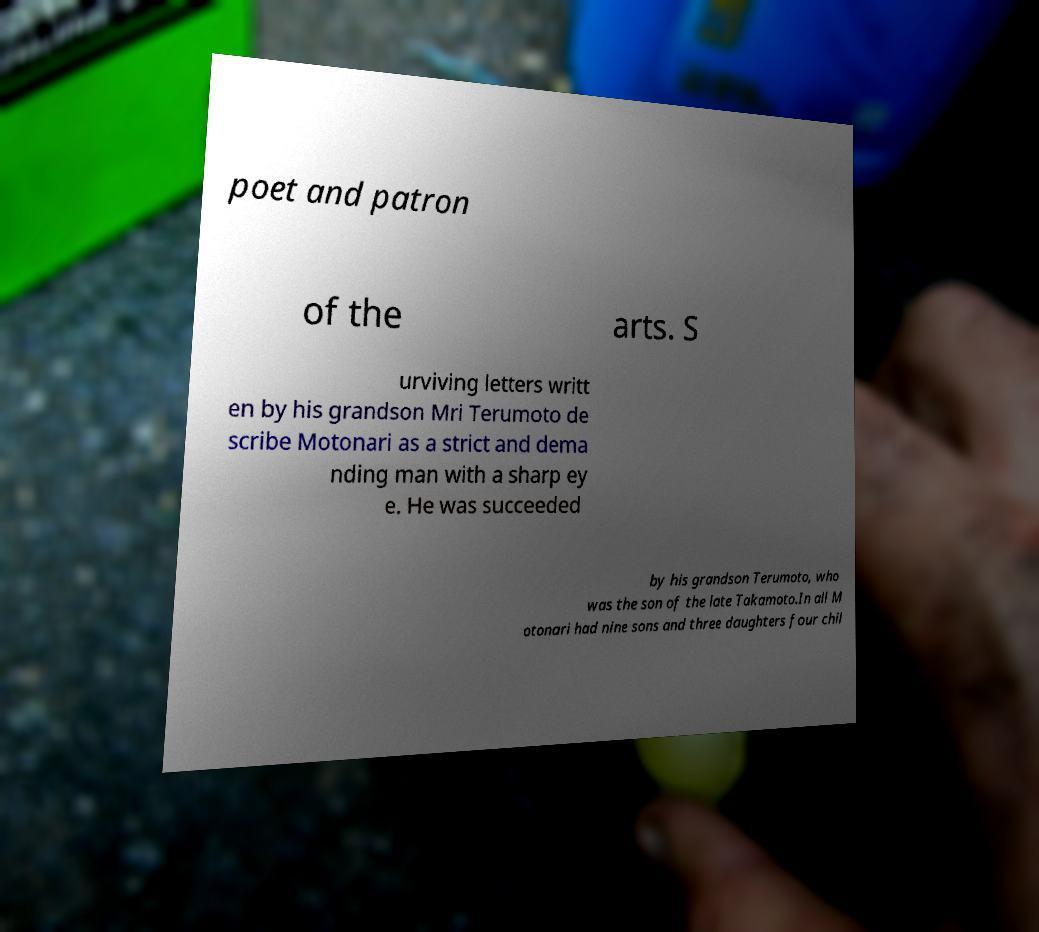I need the written content from this picture converted into text. Can you do that? poet and patron of the arts. S urviving letters writt en by his grandson Mri Terumoto de scribe Motonari as a strict and dema nding man with a sharp ey e. He was succeeded by his grandson Terumoto, who was the son of the late Takamoto.In all M otonari had nine sons and three daughters four chil 